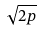Convert formula to latex. <formula><loc_0><loc_0><loc_500><loc_500>\sqrt { 2 p }</formula> 